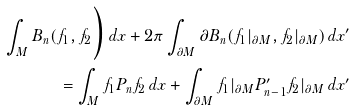Convert formula to latex. <formula><loc_0><loc_0><loc_500><loc_500>\int _ { M } B _ { n } ( f _ { 1 } , f _ { 2 } \Big ) \, d x + 2 \pi \int _ { \partial M } \partial B _ { n } ( f _ { 1 } | _ { \partial M } , f _ { 2 } | _ { \partial M } ) \, d x ^ { \prime } \\ = \int _ { M } f _ { 1 } P _ { n } f _ { 2 } \, d x + \int _ { \partial M } f _ { 1 } | _ { \partial M } P ^ { \prime } _ { n - 1 } f _ { 2 } | _ { \partial M } \, d x ^ { \prime }</formula> 